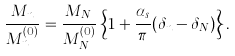Convert formula to latex. <formula><loc_0><loc_0><loc_500><loc_500>\frac { M _ { n } } { M _ { n } ^ { ( 0 ) } } = \frac { M _ { N } } { M _ { N } ^ { ( 0 ) } } \left \{ 1 + \frac { \alpha _ { s } } \pi ( \delta _ { n } - \delta _ { N } ) \right \} .</formula> 